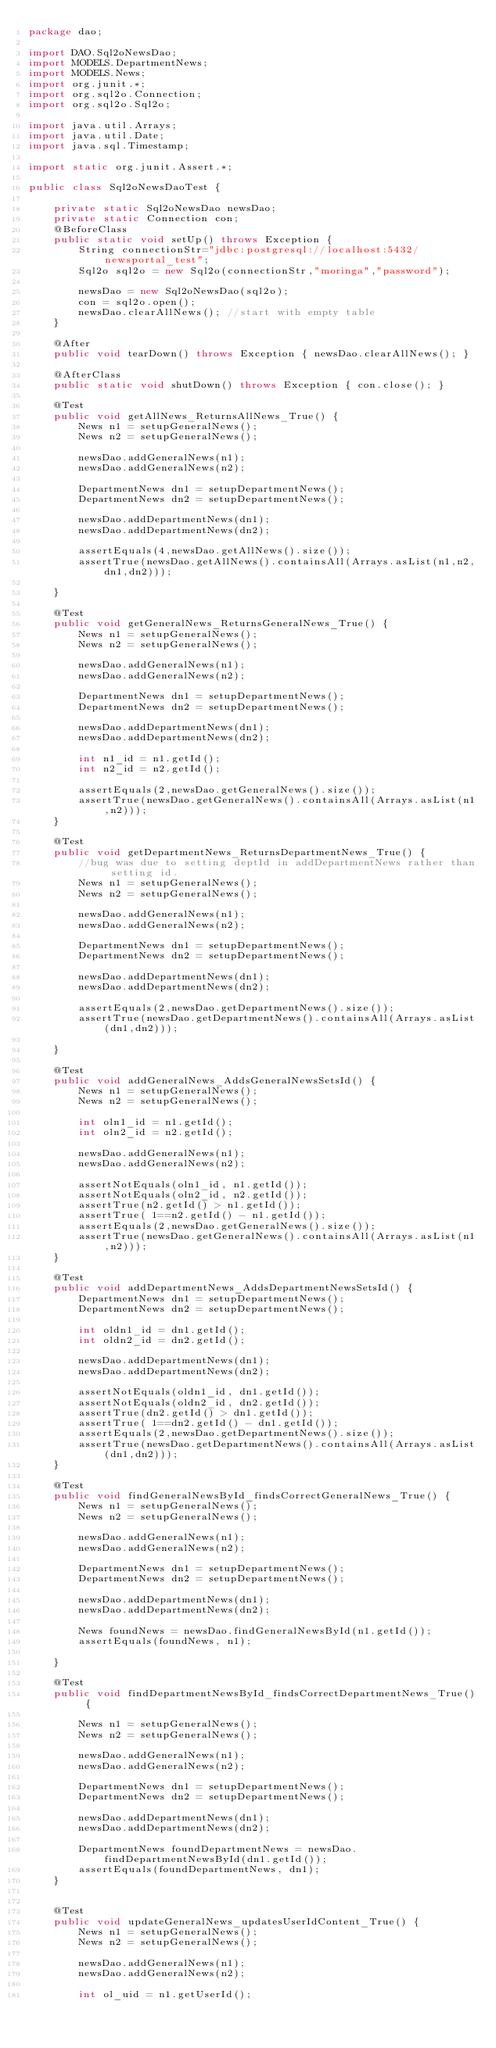Convert code to text. <code><loc_0><loc_0><loc_500><loc_500><_Java_>package dao;

import DAO.Sql2oNewsDao;
import MODELS.DepartmentNews;
import MODELS.News;
import org.junit.*;
import org.sql2o.Connection;
import org.sql2o.Sql2o;

import java.util.Arrays;
import java.util.Date;
import java.sql.Timestamp;

import static org.junit.Assert.*;

public class Sql2oNewsDaoTest {

    private static Sql2oNewsDao newsDao;
    private static Connection con;
    @BeforeClass
    public static void setUp() throws Exception {
        String connectionStr="jdbc:postgresql://localhost:5432/newsportal_test";
        Sql2o sql2o = new Sql2o(connectionStr,"moringa","password");

        newsDao = new Sql2oNewsDao(sql2o);
        con = sql2o.open();
        newsDao.clearAllNews(); //start with empty table
    }

    @After
    public void tearDown() throws Exception { newsDao.clearAllNews(); }

    @AfterClass
    public static void shutDown() throws Exception { con.close(); }

    @Test
    public void getAllNews_ReturnsAllNews_True() {
        News n1 = setupGeneralNews();
        News n2 = setupGeneralNews();

        newsDao.addGeneralNews(n1);
        newsDao.addGeneralNews(n2);

        DepartmentNews dn1 = setupDepartmentNews();
        DepartmentNews dn2 = setupDepartmentNews();

        newsDao.addDepartmentNews(dn1);
        newsDao.addDepartmentNews(dn2);

        assertEquals(4,newsDao.getAllNews().size());
        assertTrue(newsDao.getAllNews().containsAll(Arrays.asList(n1,n2,dn1,dn2)));

    }

    @Test
    public void getGeneralNews_ReturnsGeneralNews_True() {
        News n1 = setupGeneralNews();
        News n2 = setupGeneralNews();

        newsDao.addGeneralNews(n1);
        newsDao.addGeneralNews(n2);

        DepartmentNews dn1 = setupDepartmentNews();
        DepartmentNews dn2 = setupDepartmentNews();

        newsDao.addDepartmentNews(dn1);
        newsDao.addDepartmentNews(dn2);

        int n1_id = n1.getId();
        int n2_id = n2.getId();

        assertEquals(2,newsDao.getGeneralNews().size());
        assertTrue(newsDao.getGeneralNews().containsAll(Arrays.asList(n1,n2)));
    }

    @Test
    public void getDepartmentNews_ReturnsDepartmentNews_True() {
        //bug was due to setting deptId in addDepartmentNews rather than setting id.
        News n1 = setupGeneralNews();
        News n2 = setupGeneralNews();

        newsDao.addGeneralNews(n1);
        newsDao.addGeneralNews(n2);

        DepartmentNews dn1 = setupDepartmentNews();
        DepartmentNews dn2 = setupDepartmentNews();

        newsDao.addDepartmentNews(dn1);
        newsDao.addDepartmentNews(dn2);

        assertEquals(2,newsDao.getDepartmentNews().size());
        assertTrue(newsDao.getDepartmentNews().containsAll(Arrays.asList(dn1,dn2)));

    }

    @Test
    public void addGeneralNews_AddsGeneralNewsSetsId() {
        News n1 = setupGeneralNews();
        News n2 = setupGeneralNews();

        int oln1_id = n1.getId();
        int oln2_id = n2.getId();

        newsDao.addGeneralNews(n1);
        newsDao.addGeneralNews(n2);

        assertNotEquals(oln1_id, n1.getId());
        assertNotEquals(oln2_id, n2.getId());
        assertTrue(n2.getId() > n1.getId());
        assertTrue( 1==n2.getId() - n1.getId());
        assertEquals(2,newsDao.getGeneralNews().size());
        assertTrue(newsDao.getGeneralNews().containsAll(Arrays.asList(n1,n2)));
    }

    @Test
    public void addDepartmentNews_AddsDepartmentNewsSetsId() {
        DepartmentNews dn1 = setupDepartmentNews();
        DepartmentNews dn2 = setupDepartmentNews();

        int oldn1_id = dn1.getId();
        int oldn2_id = dn2.getId();

        newsDao.addDepartmentNews(dn1);
        newsDao.addDepartmentNews(dn2);

        assertNotEquals(oldn1_id, dn1.getId());
        assertNotEquals(oldn2_id, dn2.getId());
        assertTrue(dn2.getId() > dn1.getId());
        assertTrue( 1==dn2.getId() - dn1.getId());
        assertEquals(2,newsDao.getDepartmentNews().size());
        assertTrue(newsDao.getDepartmentNews().containsAll(Arrays.asList(dn1,dn2)));
    }

    @Test
    public void findGeneralNewsById_findsCorrectGeneralNews_True() {
        News n1 = setupGeneralNews();
        News n2 = setupGeneralNews();

        newsDao.addGeneralNews(n1);
        newsDao.addGeneralNews(n2);

        DepartmentNews dn1 = setupDepartmentNews();
        DepartmentNews dn2 = setupDepartmentNews();

        newsDao.addDepartmentNews(dn1);
        newsDao.addDepartmentNews(dn2);

        News foundNews = newsDao.findGeneralNewsById(n1.getId());
        assertEquals(foundNews, n1);

    }

    @Test
    public void findDepartmentNewsById_findsCorrectDepartmentNews_True() {

        News n1 = setupGeneralNews();
        News n2 = setupGeneralNews();

        newsDao.addGeneralNews(n1);
        newsDao.addGeneralNews(n2);

        DepartmentNews dn1 = setupDepartmentNews();
        DepartmentNews dn2 = setupDepartmentNews();

        newsDao.addDepartmentNews(dn1);
        newsDao.addDepartmentNews(dn2);

        DepartmentNews foundDepartmentNews = newsDao.findDepartmentNewsById(dn1.getId());
        assertEquals(foundDepartmentNews, dn1);
    }


    @Test
    public void updateGeneralNews_updatesUserIdContent_True() {
        News n1 = setupGeneralNews();
        News n2 = setupGeneralNews();

        newsDao.addGeneralNews(n1);
        newsDao.addGeneralNews(n2);

        int ol_uid = n1.getUserId();</code> 